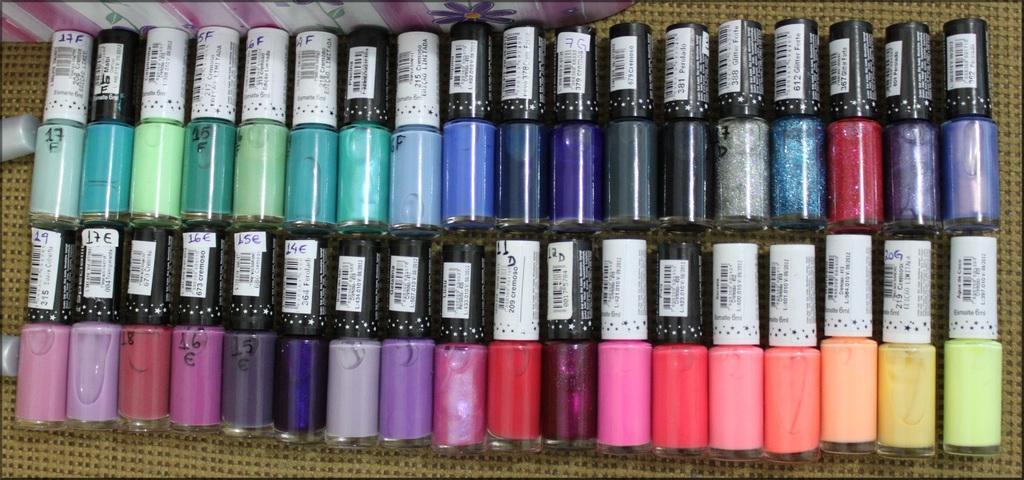Describe this image in one or two sentences. These are bottles. 